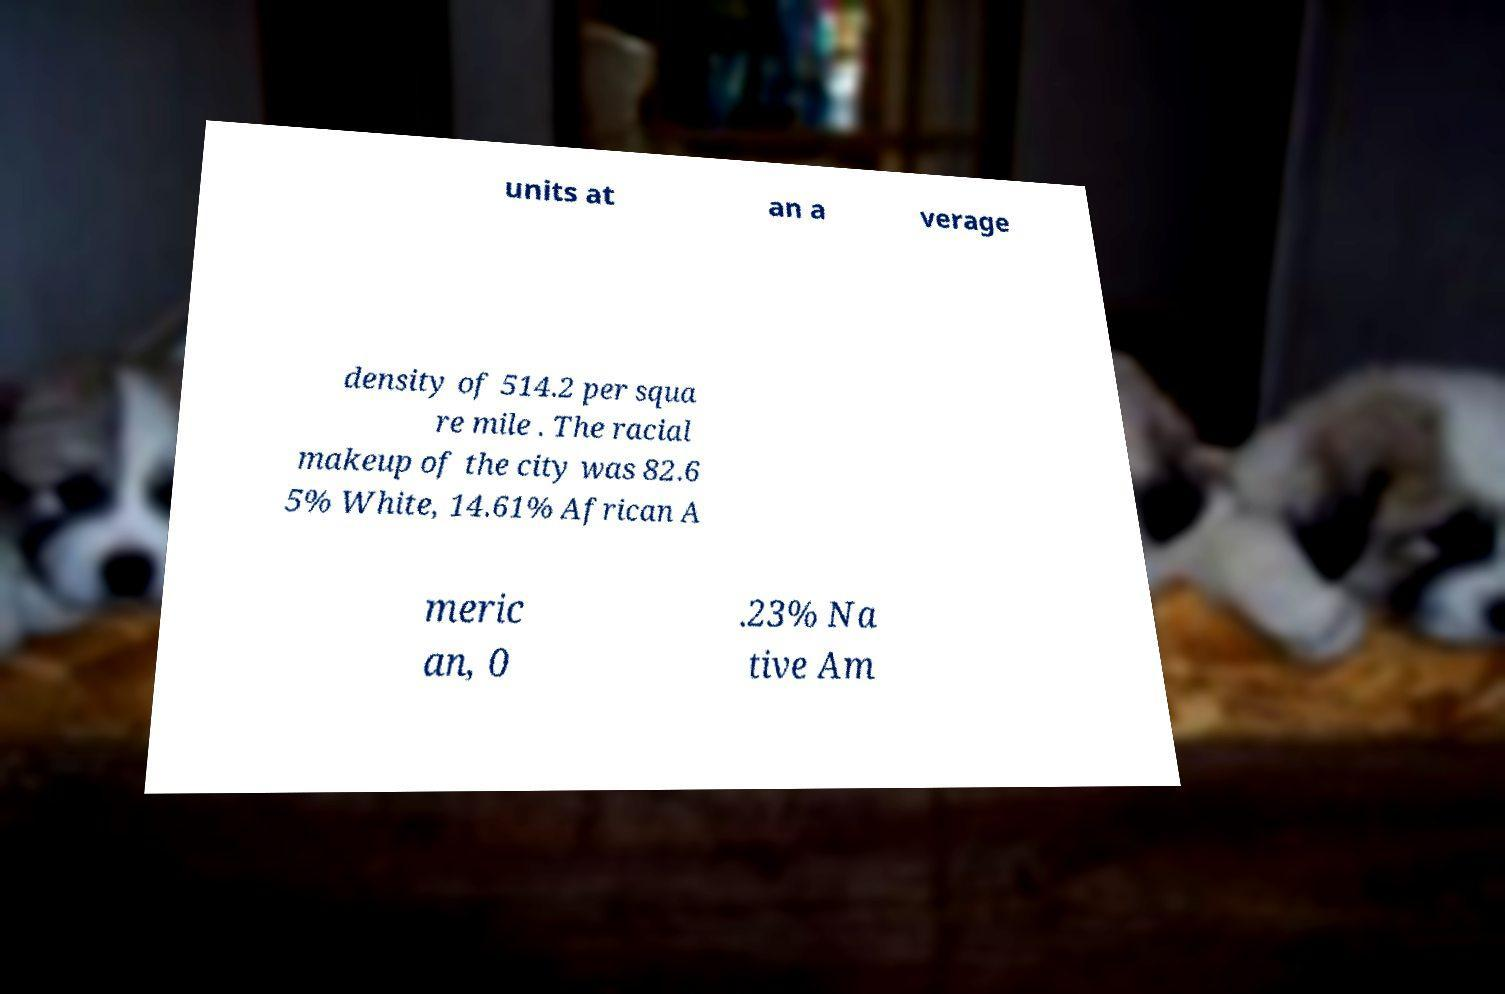Could you extract and type out the text from this image? units at an a verage density of 514.2 per squa re mile . The racial makeup of the city was 82.6 5% White, 14.61% African A meric an, 0 .23% Na tive Am 